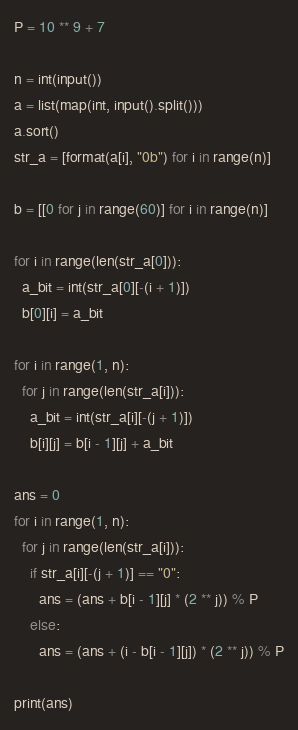Convert code to text. <code><loc_0><loc_0><loc_500><loc_500><_Python_>P = 10 ** 9 + 7
 
n = int(input())
a = list(map(int, input().split()))
a.sort()
str_a = [format(a[i], "0b") for i in range(n)]

b = [[0 for j in range(60)] for i in range(n)]
 
for i in range(len(str_a[0])):
  a_bit = int(str_a[0][-(i + 1)])
  b[0][i] = a_bit
 
for i in range(1, n):
  for j in range(len(str_a[i])):
    a_bit = int(str_a[i][-(j + 1)])
    b[i][j] = b[i - 1][j] + a_bit
    
ans = 0
for i in range(1, n):
  for j in range(len(str_a[i])):
    if str_a[i][-(j + 1)] == "0":
      ans = (ans + b[i - 1][j] * (2 ** j)) % P
    else:
      ans = (ans + (i - b[i - 1][j]) * (2 ** j)) % P
 
print(ans)</code> 